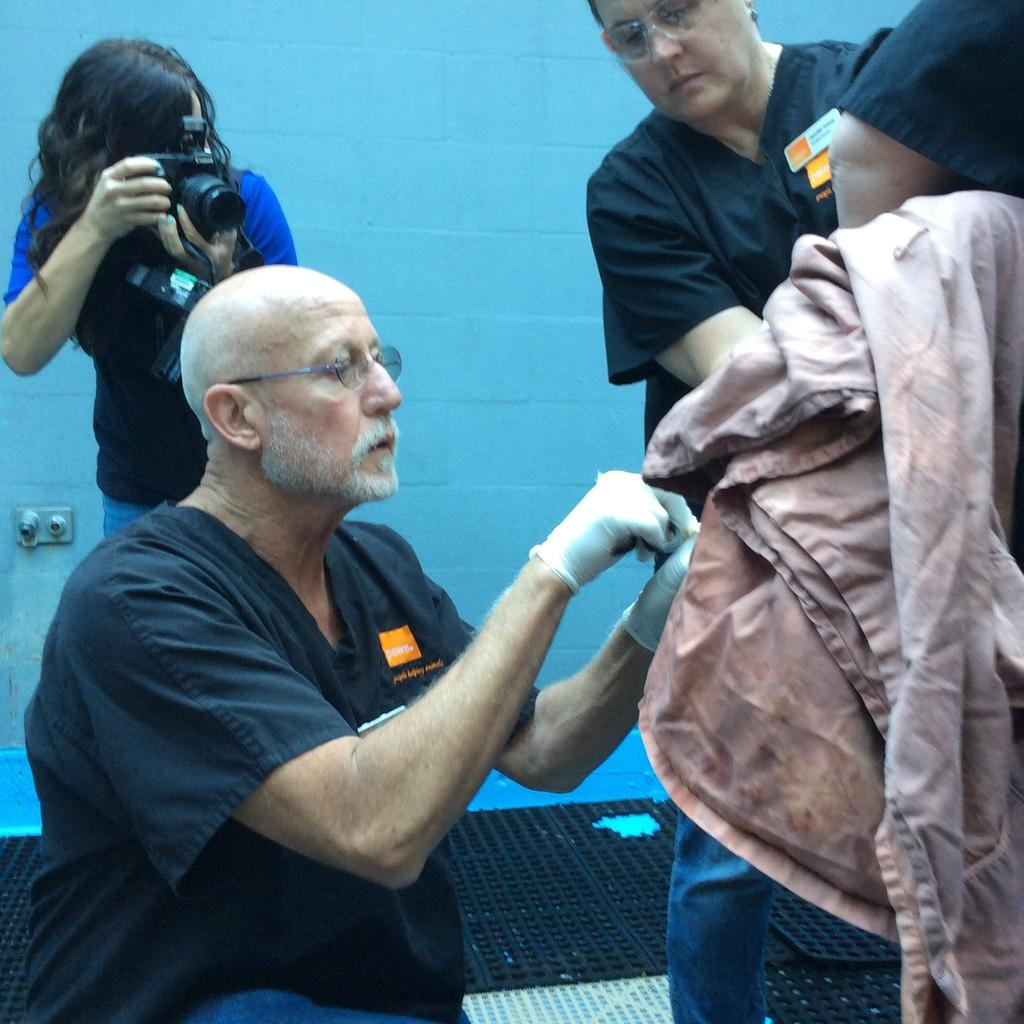How many people are in the image? There are four persons in the image. What is one person doing in the image? One person is holding a camera. What is another person holding in the image? One person is holding an unspecified object. What can be seen in the image that represents a celestial body? There is a representation of Mars visible in the image. What is in the background of the image? There is a wall in the background of the image. Where is the nest located in the image? There is no nest present in the image. Can you describe the woman in the image? There is no woman present in the image; the four persons mentioned are not specified as male or female. What type of brick is used to construct the wall in the image? There is no information about the type of brick used to construct the wall in the image. 